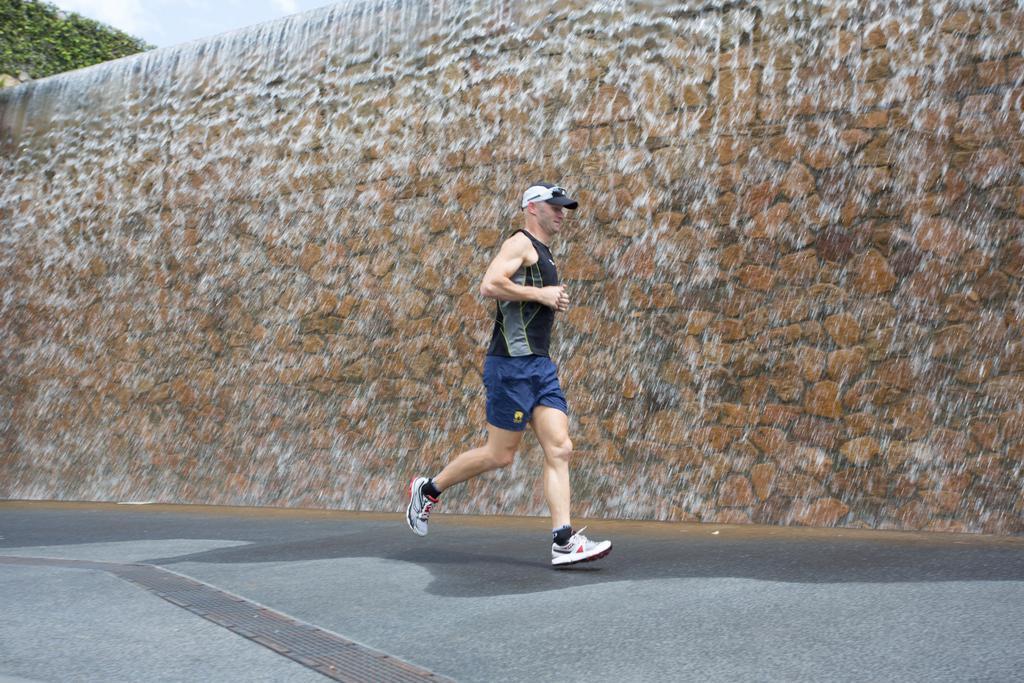Please provide a concise description of this image. In this picture I can observe a man running on the road. He is wearing black color t-shirt and a cap on his head. In the background there is a wall. I can observe water falling from the top of the wall. There is a sky in the background. 